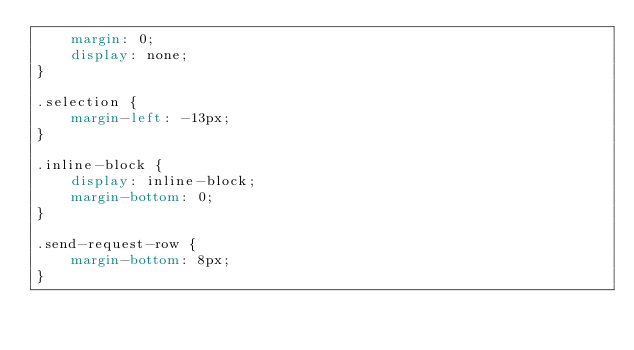Convert code to text. <code><loc_0><loc_0><loc_500><loc_500><_CSS_>    margin: 0;
    display: none;
}

.selection {
    margin-left: -13px;
}

.inline-block {
    display: inline-block;
    margin-bottom: 0;
}

.send-request-row {
    margin-bottom: 8px;
}</code> 